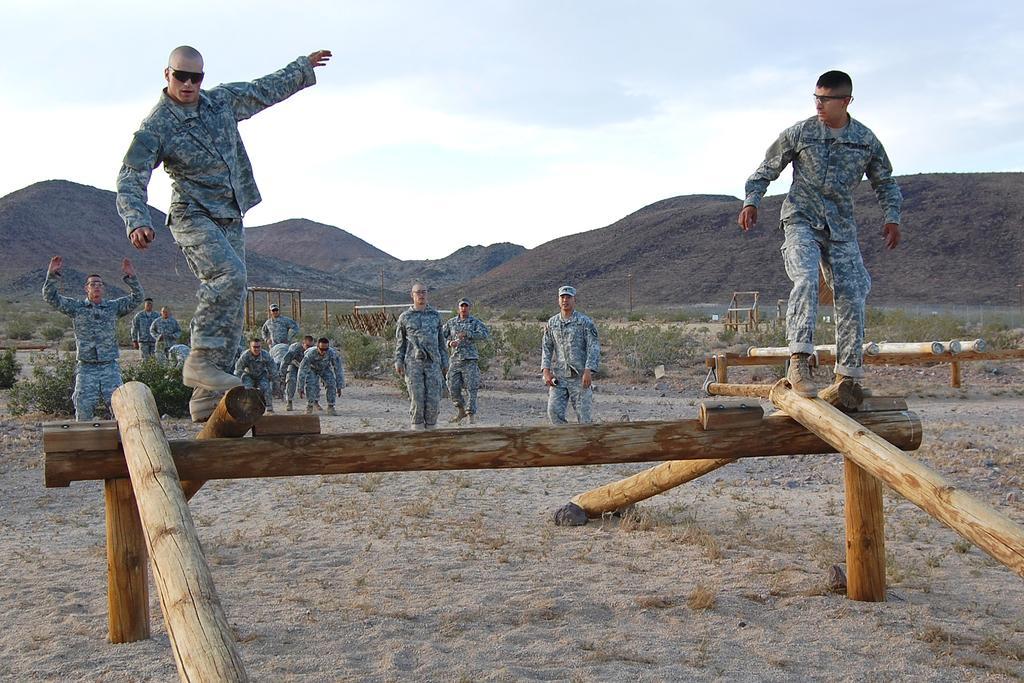How would you summarize this image in a sentence or two? In this image I can see number of people where in the front I can see two of them are standing on wooden things and in the background I can see most of them are standing on the ground. I can also see all of them are wearing uniforms. In the background I can also see few plants, few more wooden things, hill's, clouds and the sky. 